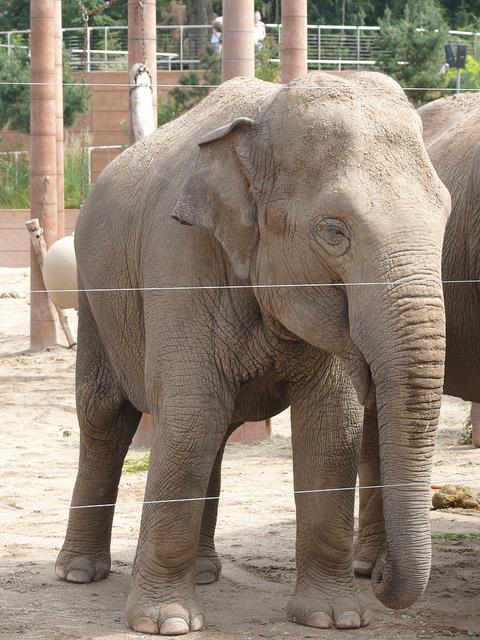How many legs does this animal have?
Be succinct. 4. Is this elephant in the wild?
Answer briefly. No. What kind of fence is in front of the elephant?
Answer briefly. Wire. 